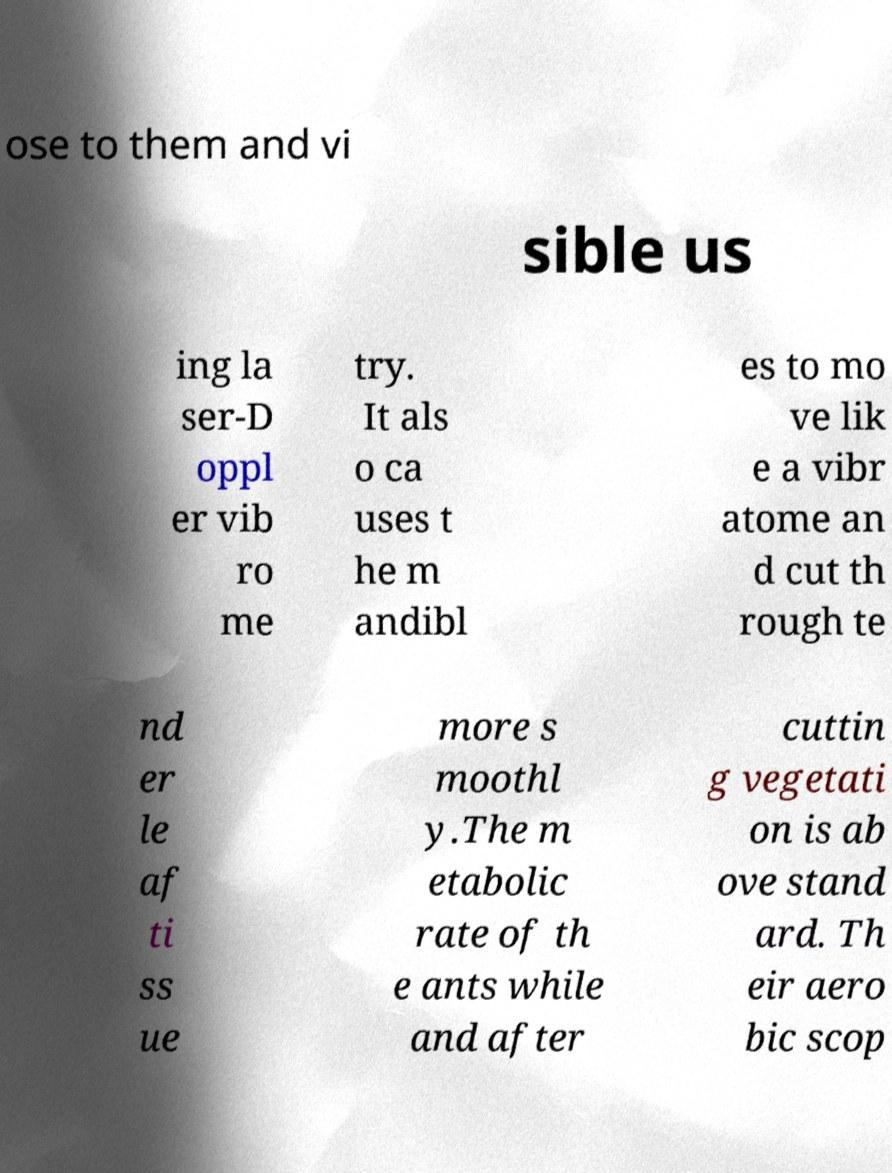Can you accurately transcribe the text from the provided image for me? ose to them and vi sible us ing la ser-D oppl er vib ro me try. It als o ca uses t he m andibl es to mo ve lik e a vibr atome an d cut th rough te nd er le af ti ss ue more s moothl y.The m etabolic rate of th e ants while and after cuttin g vegetati on is ab ove stand ard. Th eir aero bic scop 